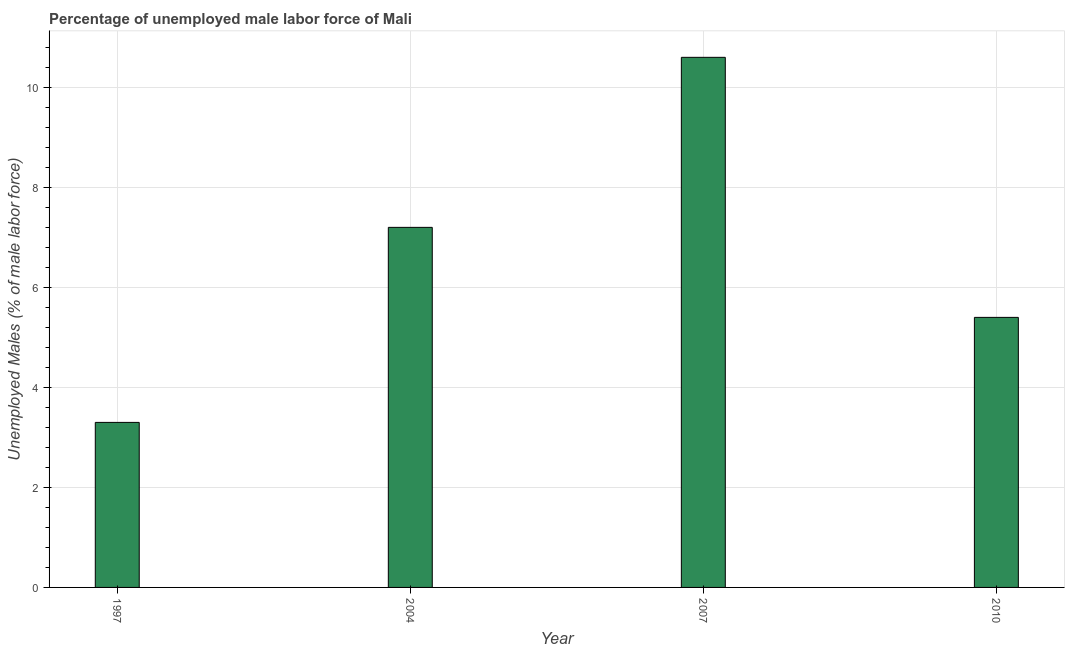Does the graph contain any zero values?
Provide a succinct answer. No. Does the graph contain grids?
Make the answer very short. Yes. What is the title of the graph?
Your answer should be compact. Percentage of unemployed male labor force of Mali. What is the label or title of the X-axis?
Give a very brief answer. Year. What is the label or title of the Y-axis?
Make the answer very short. Unemployed Males (% of male labor force). What is the total unemployed male labour force in 2010?
Offer a terse response. 5.4. Across all years, what is the maximum total unemployed male labour force?
Provide a short and direct response. 10.6. Across all years, what is the minimum total unemployed male labour force?
Offer a terse response. 3.3. What is the sum of the total unemployed male labour force?
Make the answer very short. 26.5. What is the average total unemployed male labour force per year?
Make the answer very short. 6.62. What is the median total unemployed male labour force?
Give a very brief answer. 6.3. What is the ratio of the total unemployed male labour force in 2004 to that in 2010?
Make the answer very short. 1.33. What is the difference between the highest and the second highest total unemployed male labour force?
Keep it short and to the point. 3.4. Is the sum of the total unemployed male labour force in 1997 and 2004 greater than the maximum total unemployed male labour force across all years?
Offer a very short reply. No. In how many years, is the total unemployed male labour force greater than the average total unemployed male labour force taken over all years?
Your response must be concise. 2. How many years are there in the graph?
Ensure brevity in your answer.  4. What is the difference between two consecutive major ticks on the Y-axis?
Ensure brevity in your answer.  2. What is the Unemployed Males (% of male labor force) of 1997?
Keep it short and to the point. 3.3. What is the Unemployed Males (% of male labor force) in 2004?
Make the answer very short. 7.2. What is the Unemployed Males (% of male labor force) in 2007?
Your answer should be very brief. 10.6. What is the Unemployed Males (% of male labor force) in 2010?
Your answer should be compact. 5.4. What is the difference between the Unemployed Males (% of male labor force) in 2004 and 2010?
Make the answer very short. 1.8. What is the difference between the Unemployed Males (% of male labor force) in 2007 and 2010?
Give a very brief answer. 5.2. What is the ratio of the Unemployed Males (% of male labor force) in 1997 to that in 2004?
Offer a terse response. 0.46. What is the ratio of the Unemployed Males (% of male labor force) in 1997 to that in 2007?
Your answer should be very brief. 0.31. What is the ratio of the Unemployed Males (% of male labor force) in 1997 to that in 2010?
Your response must be concise. 0.61. What is the ratio of the Unemployed Males (% of male labor force) in 2004 to that in 2007?
Your answer should be very brief. 0.68. What is the ratio of the Unemployed Males (% of male labor force) in 2004 to that in 2010?
Your response must be concise. 1.33. What is the ratio of the Unemployed Males (% of male labor force) in 2007 to that in 2010?
Give a very brief answer. 1.96. 